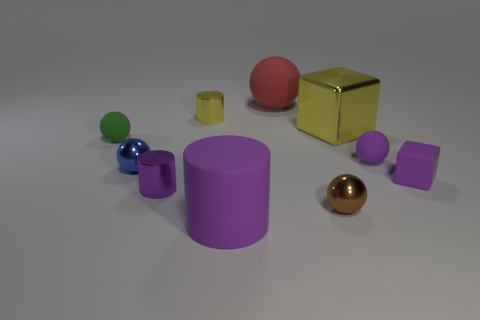How many blue spheres are behind the metal ball on the left side of the brown thing?
Your answer should be compact. 0. What size is the yellow metal object that is right of the cylinder behind the small purple matte object that is to the left of the small block?
Offer a terse response. Large. There is a big matte thing behind the cube that is behind the blue shiny sphere; what color is it?
Keep it short and to the point. Red. What number of other objects are the same material as the tiny green thing?
Your response must be concise. 4. What number of other objects are the same color as the big rubber cylinder?
Provide a short and direct response. 3. What material is the yellow cylinder that is on the left side of the small shiny thing that is in front of the purple shiny cylinder made of?
Make the answer very short. Metal. Is there a tiny gray rubber cylinder?
Provide a short and direct response. No. There is a yellow object on the right side of the metal cylinder behind the yellow metallic block; what is its size?
Offer a very short reply. Large. Are there more metal cylinders in front of the tiny green object than tiny green balls in front of the big purple object?
Provide a succinct answer. Yes. What number of balls are either things or small yellow objects?
Ensure brevity in your answer.  5. 